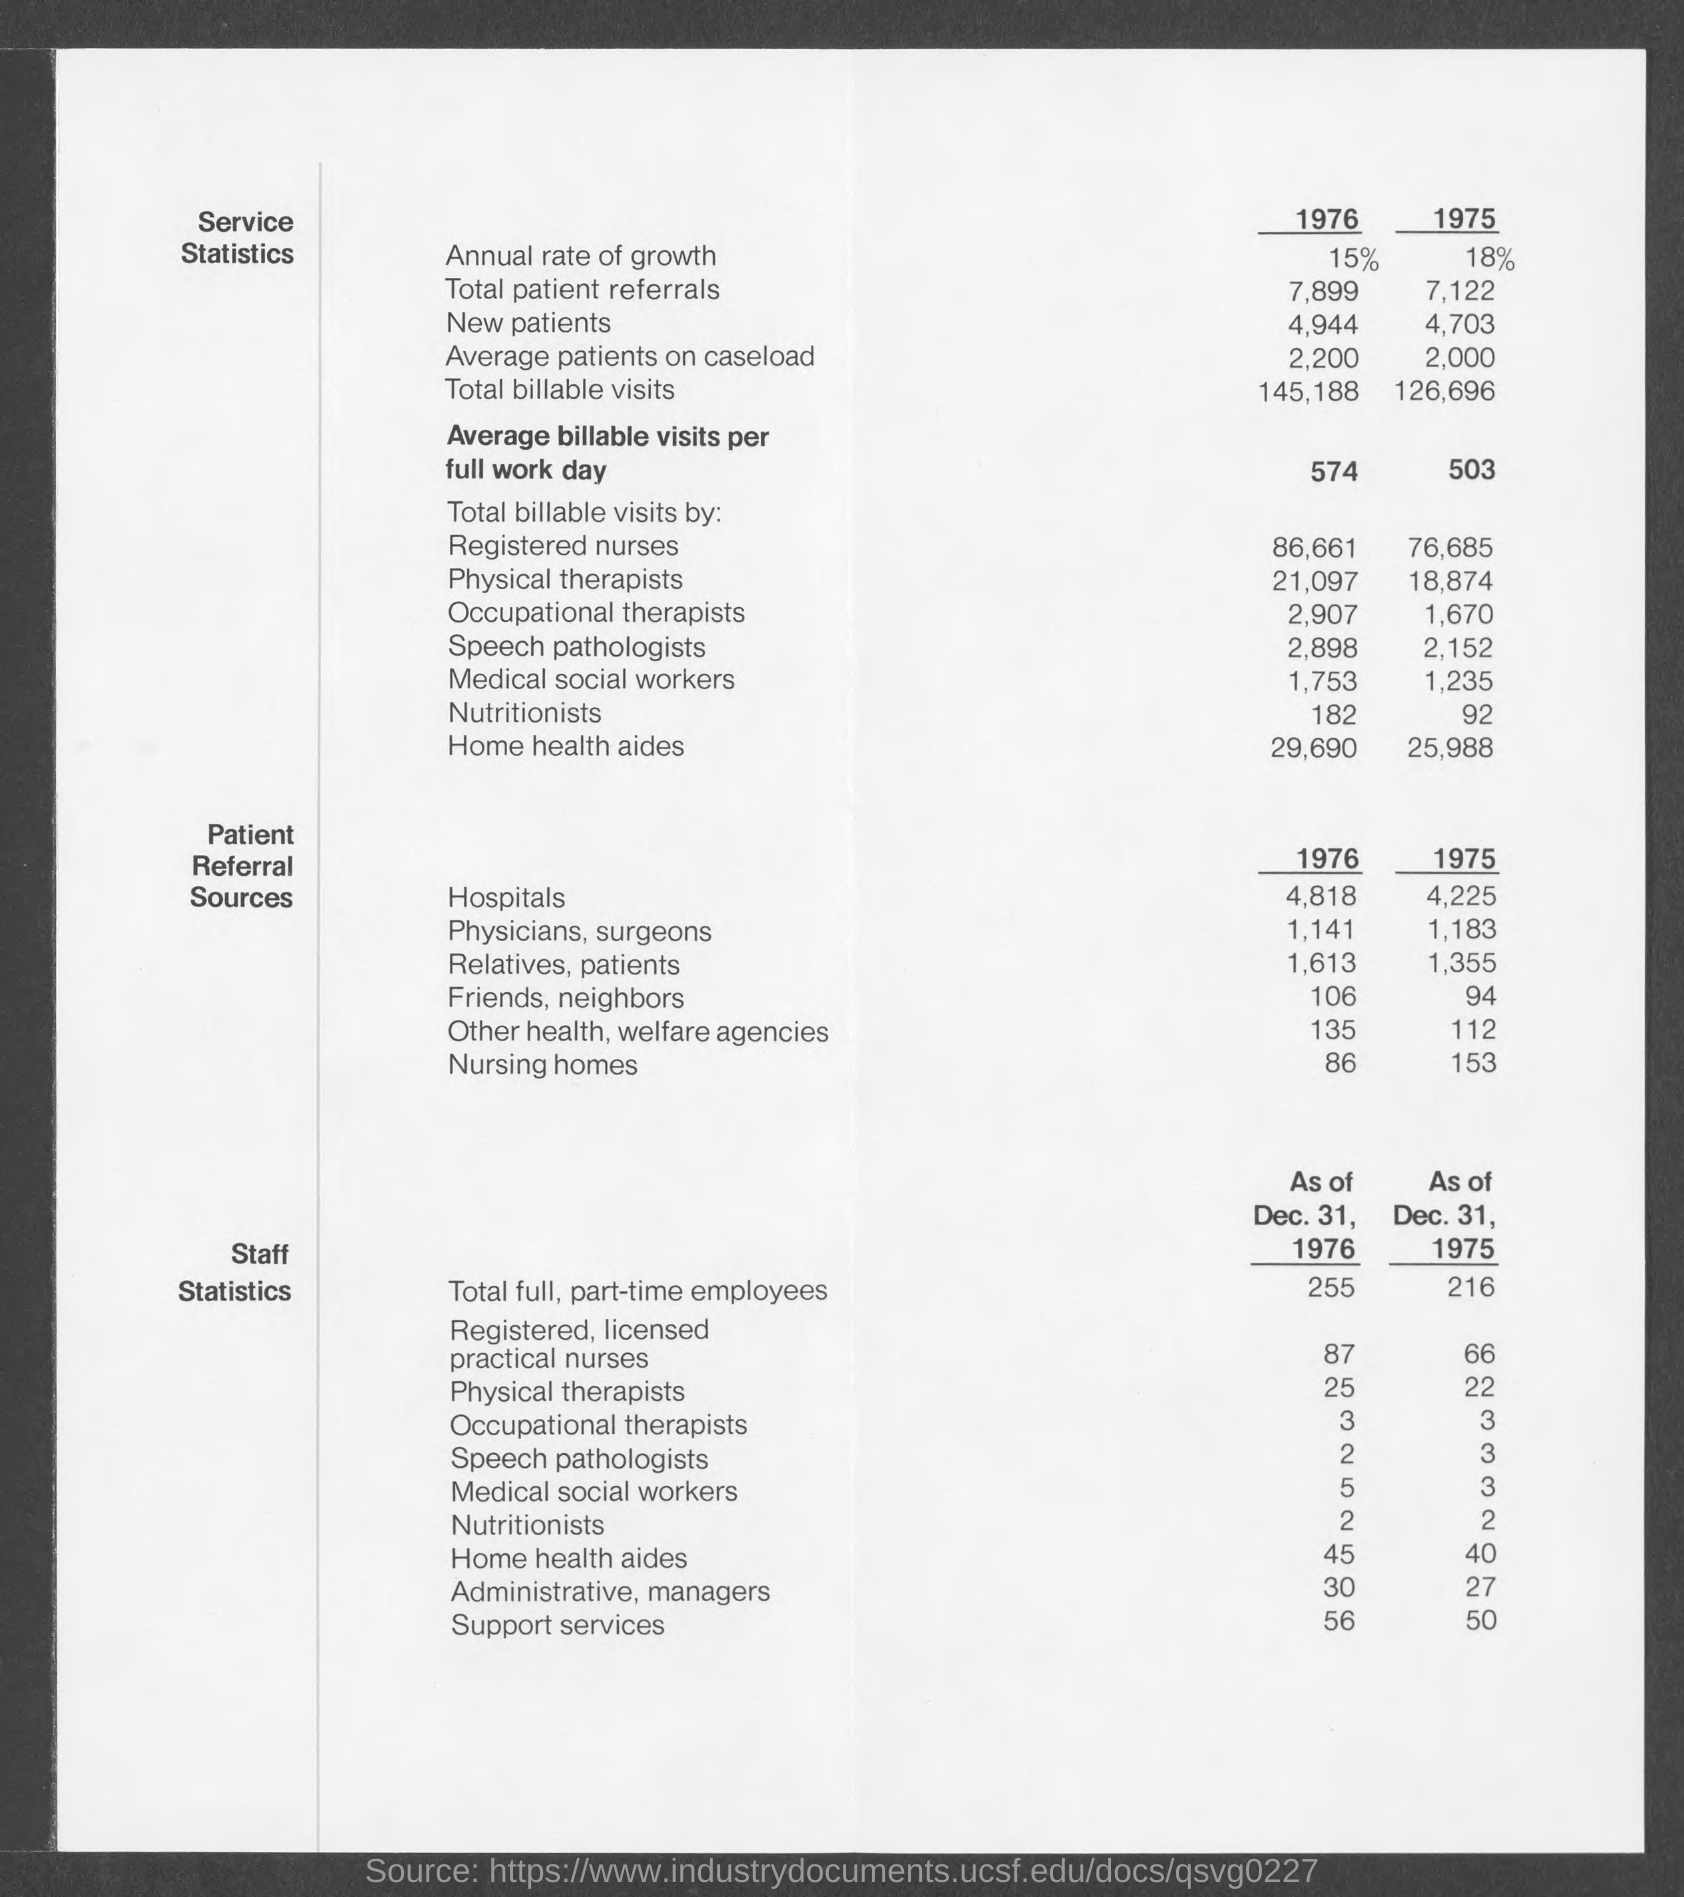What is the annual rate of growth in 1976?
Provide a short and direct response. 15%. What is the annual rate of growth in 1975?
Give a very brief answer. 18%. What is the total patient referrals in 1976?
Ensure brevity in your answer.  7,899. What is the total patient referral in 1975?
Your answer should be very brief. 7,122. 